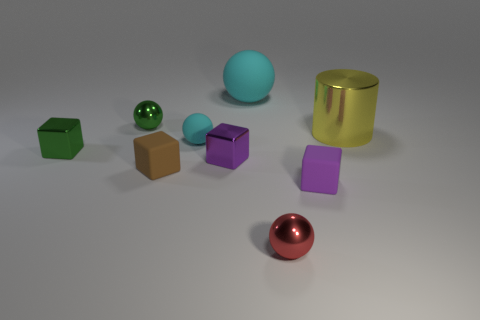What material is the green ball that is the same size as the purple matte cube?
Keep it short and to the point. Metal. What number of small things are cyan things or green objects?
Your answer should be compact. 3. Are any big red objects visible?
Your response must be concise. No. There is another cube that is the same material as the tiny green cube; what size is it?
Provide a succinct answer. Small. Are the large sphere and the small cyan ball made of the same material?
Offer a terse response. Yes. How many other objects are there of the same material as the brown cube?
Ensure brevity in your answer.  3. What number of metallic objects are in front of the yellow shiny cylinder and right of the green cube?
Your response must be concise. 2. What color is the small rubber sphere?
Provide a succinct answer. Cyan. What material is the brown thing that is the same shape as the tiny purple shiny object?
Provide a succinct answer. Rubber. Do the large rubber sphere and the tiny rubber sphere have the same color?
Provide a succinct answer. Yes. 